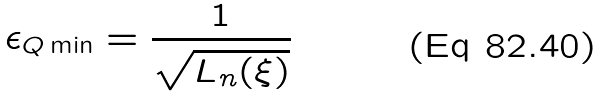<formula> <loc_0><loc_0><loc_500><loc_500>\epsilon _ { Q \min } = \frac { 1 } { \sqrt { L _ { n } ( \xi ) } }</formula> 